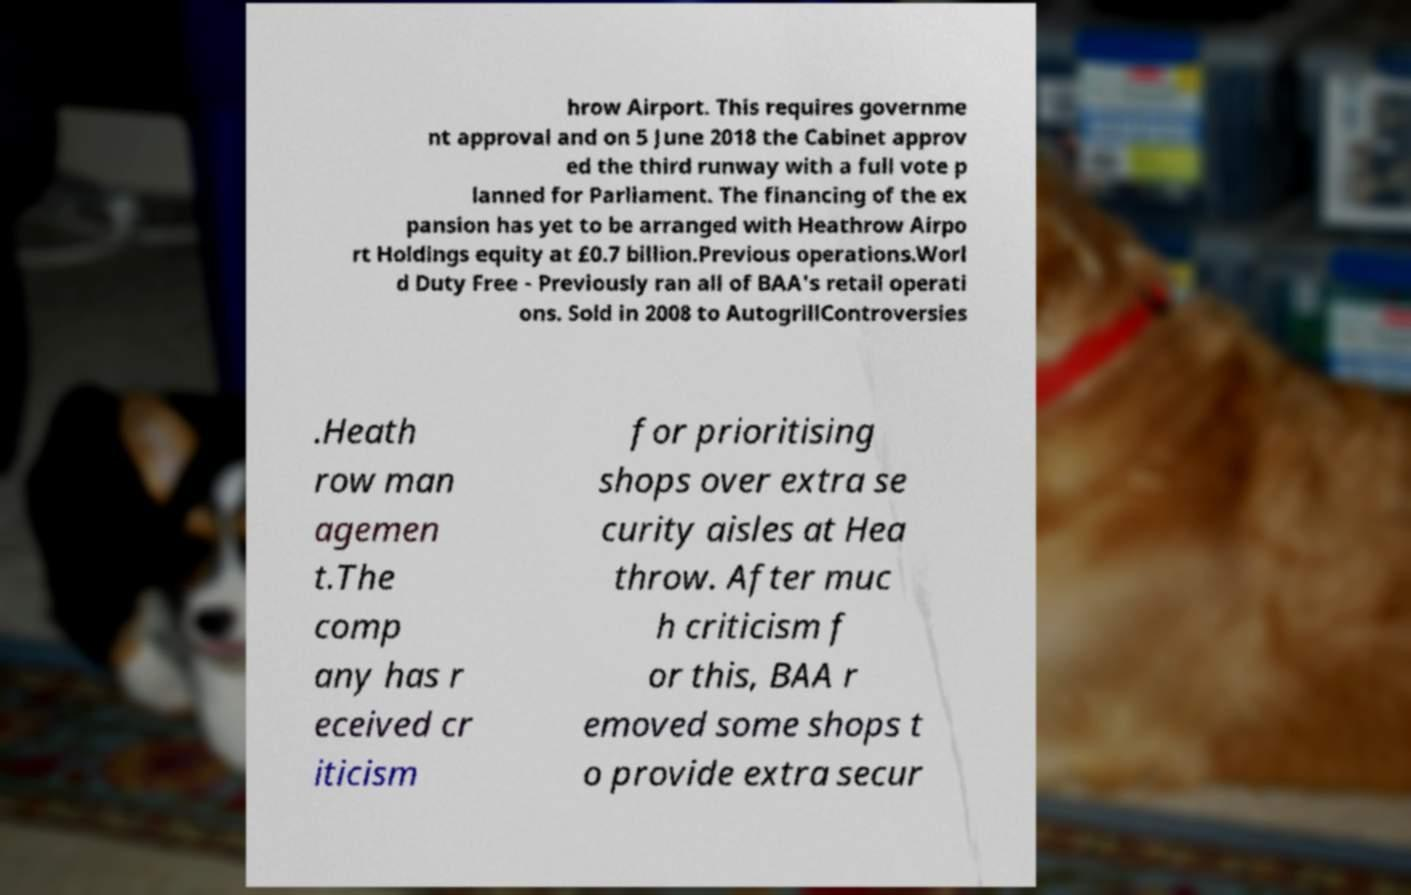I need the written content from this picture converted into text. Can you do that? hrow Airport. This requires governme nt approval and on 5 June 2018 the Cabinet approv ed the third runway with a full vote p lanned for Parliament. The financing of the ex pansion has yet to be arranged with Heathrow Airpo rt Holdings equity at £0.7 billion.Previous operations.Worl d Duty Free - Previously ran all of BAA's retail operati ons. Sold in 2008 to AutogrillControversies .Heath row man agemen t.The comp any has r eceived cr iticism for prioritising shops over extra se curity aisles at Hea throw. After muc h criticism f or this, BAA r emoved some shops t o provide extra secur 